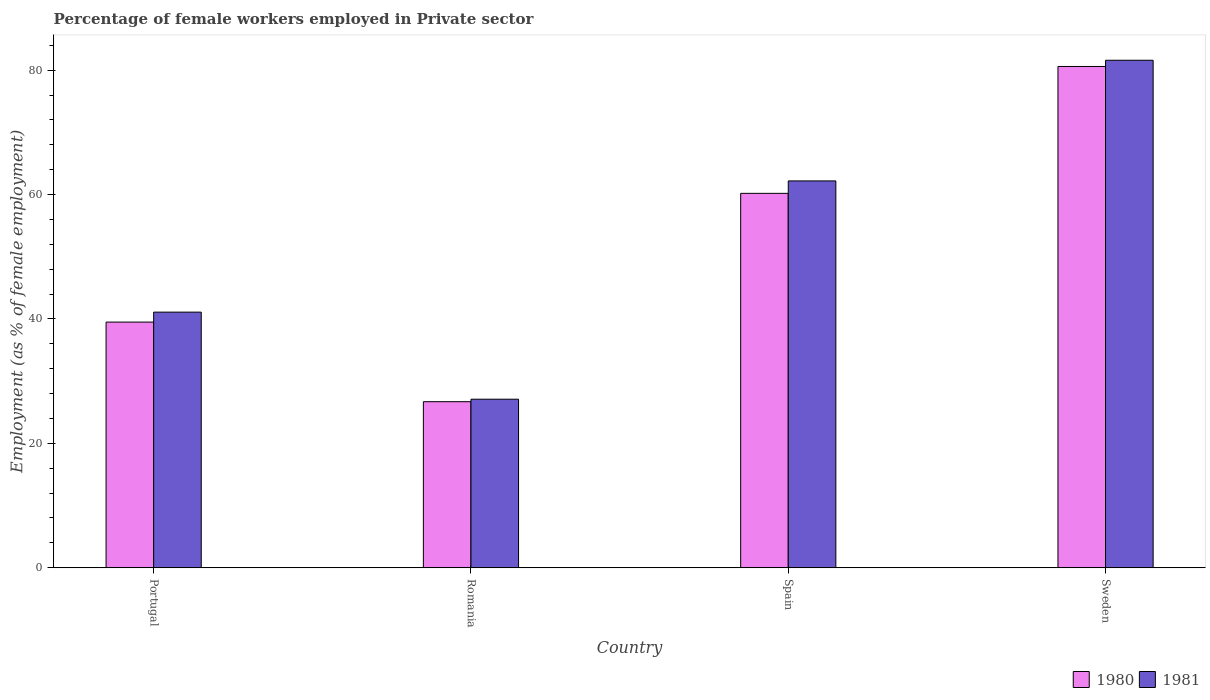How many different coloured bars are there?
Offer a terse response. 2. How many groups of bars are there?
Your response must be concise. 4. How many bars are there on the 4th tick from the right?
Offer a very short reply. 2. What is the label of the 4th group of bars from the left?
Offer a terse response. Sweden. In how many cases, is the number of bars for a given country not equal to the number of legend labels?
Keep it short and to the point. 0. What is the percentage of females employed in Private sector in 1981 in Portugal?
Give a very brief answer. 41.1. Across all countries, what is the maximum percentage of females employed in Private sector in 1980?
Your answer should be very brief. 80.6. Across all countries, what is the minimum percentage of females employed in Private sector in 1981?
Offer a terse response. 27.1. In which country was the percentage of females employed in Private sector in 1981 maximum?
Ensure brevity in your answer.  Sweden. In which country was the percentage of females employed in Private sector in 1980 minimum?
Provide a short and direct response. Romania. What is the total percentage of females employed in Private sector in 1980 in the graph?
Your answer should be compact. 207. What is the difference between the percentage of females employed in Private sector in 1981 in Romania and that in Sweden?
Offer a terse response. -54.5. What is the difference between the percentage of females employed in Private sector in 1981 in Portugal and the percentage of females employed in Private sector in 1980 in Romania?
Give a very brief answer. 14.4. What is the average percentage of females employed in Private sector in 1980 per country?
Keep it short and to the point. 51.75. What is the difference between the percentage of females employed in Private sector of/in 1981 and percentage of females employed in Private sector of/in 1980 in Spain?
Keep it short and to the point. 2. What is the ratio of the percentage of females employed in Private sector in 1980 in Portugal to that in Spain?
Your response must be concise. 0.66. Is the difference between the percentage of females employed in Private sector in 1981 in Spain and Sweden greater than the difference between the percentage of females employed in Private sector in 1980 in Spain and Sweden?
Keep it short and to the point. Yes. What is the difference between the highest and the second highest percentage of females employed in Private sector in 1981?
Provide a short and direct response. 19.4. What is the difference between the highest and the lowest percentage of females employed in Private sector in 1980?
Provide a succinct answer. 53.9. In how many countries, is the percentage of females employed in Private sector in 1980 greater than the average percentage of females employed in Private sector in 1980 taken over all countries?
Offer a very short reply. 2. Is the sum of the percentage of females employed in Private sector in 1980 in Portugal and Romania greater than the maximum percentage of females employed in Private sector in 1981 across all countries?
Give a very brief answer. No. Are all the bars in the graph horizontal?
Your response must be concise. No. How many countries are there in the graph?
Provide a succinct answer. 4. Does the graph contain any zero values?
Provide a succinct answer. No. How many legend labels are there?
Provide a succinct answer. 2. What is the title of the graph?
Offer a very short reply. Percentage of female workers employed in Private sector. What is the label or title of the Y-axis?
Ensure brevity in your answer.  Employment (as % of female employment). What is the Employment (as % of female employment) of 1980 in Portugal?
Your answer should be very brief. 39.5. What is the Employment (as % of female employment) in 1981 in Portugal?
Your answer should be compact. 41.1. What is the Employment (as % of female employment) in 1980 in Romania?
Your answer should be compact. 26.7. What is the Employment (as % of female employment) of 1981 in Romania?
Provide a short and direct response. 27.1. What is the Employment (as % of female employment) in 1980 in Spain?
Keep it short and to the point. 60.2. What is the Employment (as % of female employment) in 1981 in Spain?
Your answer should be very brief. 62.2. What is the Employment (as % of female employment) of 1980 in Sweden?
Give a very brief answer. 80.6. What is the Employment (as % of female employment) in 1981 in Sweden?
Keep it short and to the point. 81.6. Across all countries, what is the maximum Employment (as % of female employment) in 1980?
Make the answer very short. 80.6. Across all countries, what is the maximum Employment (as % of female employment) in 1981?
Give a very brief answer. 81.6. Across all countries, what is the minimum Employment (as % of female employment) in 1980?
Provide a succinct answer. 26.7. Across all countries, what is the minimum Employment (as % of female employment) of 1981?
Keep it short and to the point. 27.1. What is the total Employment (as % of female employment) in 1980 in the graph?
Your response must be concise. 207. What is the total Employment (as % of female employment) of 1981 in the graph?
Provide a short and direct response. 212. What is the difference between the Employment (as % of female employment) of 1980 in Portugal and that in Spain?
Your response must be concise. -20.7. What is the difference between the Employment (as % of female employment) of 1981 in Portugal and that in Spain?
Offer a terse response. -21.1. What is the difference between the Employment (as % of female employment) in 1980 in Portugal and that in Sweden?
Give a very brief answer. -41.1. What is the difference between the Employment (as % of female employment) of 1981 in Portugal and that in Sweden?
Make the answer very short. -40.5. What is the difference between the Employment (as % of female employment) of 1980 in Romania and that in Spain?
Offer a terse response. -33.5. What is the difference between the Employment (as % of female employment) of 1981 in Romania and that in Spain?
Provide a short and direct response. -35.1. What is the difference between the Employment (as % of female employment) of 1980 in Romania and that in Sweden?
Provide a succinct answer. -53.9. What is the difference between the Employment (as % of female employment) in 1981 in Romania and that in Sweden?
Ensure brevity in your answer.  -54.5. What is the difference between the Employment (as % of female employment) of 1980 in Spain and that in Sweden?
Give a very brief answer. -20.4. What is the difference between the Employment (as % of female employment) of 1981 in Spain and that in Sweden?
Make the answer very short. -19.4. What is the difference between the Employment (as % of female employment) of 1980 in Portugal and the Employment (as % of female employment) of 1981 in Romania?
Offer a terse response. 12.4. What is the difference between the Employment (as % of female employment) in 1980 in Portugal and the Employment (as % of female employment) in 1981 in Spain?
Offer a very short reply. -22.7. What is the difference between the Employment (as % of female employment) of 1980 in Portugal and the Employment (as % of female employment) of 1981 in Sweden?
Your answer should be very brief. -42.1. What is the difference between the Employment (as % of female employment) of 1980 in Romania and the Employment (as % of female employment) of 1981 in Spain?
Offer a very short reply. -35.5. What is the difference between the Employment (as % of female employment) in 1980 in Romania and the Employment (as % of female employment) in 1981 in Sweden?
Offer a very short reply. -54.9. What is the difference between the Employment (as % of female employment) of 1980 in Spain and the Employment (as % of female employment) of 1981 in Sweden?
Give a very brief answer. -21.4. What is the average Employment (as % of female employment) of 1980 per country?
Provide a succinct answer. 51.75. What is the difference between the Employment (as % of female employment) in 1980 and Employment (as % of female employment) in 1981 in Romania?
Ensure brevity in your answer.  -0.4. What is the ratio of the Employment (as % of female employment) of 1980 in Portugal to that in Romania?
Ensure brevity in your answer.  1.48. What is the ratio of the Employment (as % of female employment) in 1981 in Portugal to that in Romania?
Provide a succinct answer. 1.52. What is the ratio of the Employment (as % of female employment) in 1980 in Portugal to that in Spain?
Your answer should be compact. 0.66. What is the ratio of the Employment (as % of female employment) in 1981 in Portugal to that in Spain?
Your answer should be compact. 0.66. What is the ratio of the Employment (as % of female employment) in 1980 in Portugal to that in Sweden?
Your response must be concise. 0.49. What is the ratio of the Employment (as % of female employment) in 1981 in Portugal to that in Sweden?
Your response must be concise. 0.5. What is the ratio of the Employment (as % of female employment) in 1980 in Romania to that in Spain?
Keep it short and to the point. 0.44. What is the ratio of the Employment (as % of female employment) in 1981 in Romania to that in Spain?
Make the answer very short. 0.44. What is the ratio of the Employment (as % of female employment) in 1980 in Romania to that in Sweden?
Offer a very short reply. 0.33. What is the ratio of the Employment (as % of female employment) in 1981 in Romania to that in Sweden?
Give a very brief answer. 0.33. What is the ratio of the Employment (as % of female employment) of 1980 in Spain to that in Sweden?
Provide a succinct answer. 0.75. What is the ratio of the Employment (as % of female employment) in 1981 in Spain to that in Sweden?
Ensure brevity in your answer.  0.76. What is the difference between the highest and the second highest Employment (as % of female employment) in 1980?
Keep it short and to the point. 20.4. What is the difference between the highest and the lowest Employment (as % of female employment) of 1980?
Your answer should be compact. 53.9. What is the difference between the highest and the lowest Employment (as % of female employment) of 1981?
Give a very brief answer. 54.5. 